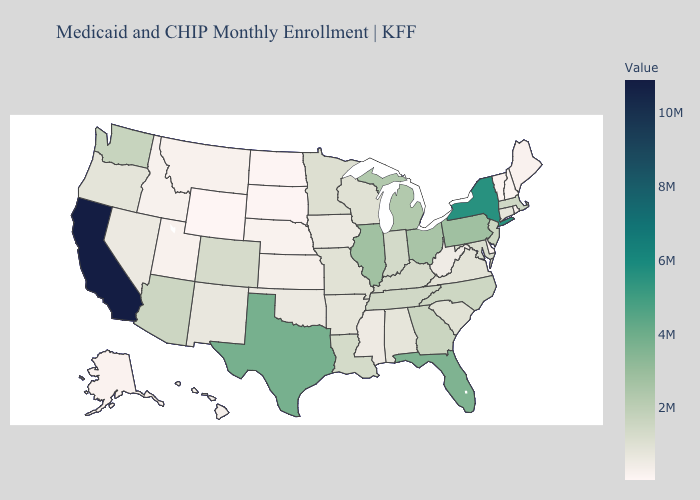Does Mississippi have the lowest value in the South?
Be succinct. No. Which states hav the highest value in the Northeast?
Keep it brief. New York. Which states have the highest value in the USA?
Be succinct. California. 